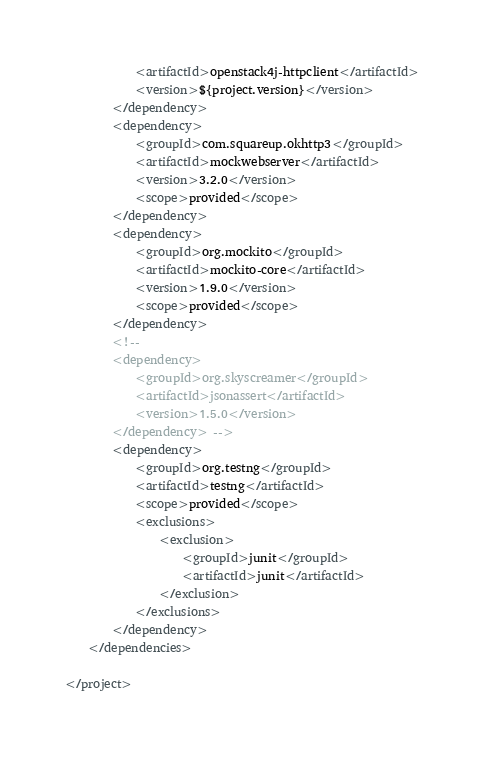Convert code to text. <code><loc_0><loc_0><loc_500><loc_500><_XML_>			<artifactId>openstack4j-httpclient</artifactId>
			<version>${project.version}</version>
		</dependency>
		<dependency>
			<groupId>com.squareup.okhttp3</groupId>
			<artifactId>mockwebserver</artifactId>
			<version>3.2.0</version>
			<scope>provided</scope>
		</dependency>
		<dependency>
			<groupId>org.mockito</groupId>
			<artifactId>mockito-core</artifactId>
			<version>1.9.0</version>
			<scope>provided</scope>
		</dependency>
		<!--
		<dependency>
		    <groupId>org.skyscreamer</groupId>
		    <artifactId>jsonassert</artifactId>
		    <version>1.5.0</version>
		</dependency> -->
		<dependency>
			<groupId>org.testng</groupId>
			<artifactId>testng</artifactId>
			<scope>provided</scope>
			<exclusions>
				<exclusion>
					<groupId>junit</groupId>
					<artifactId>junit</artifactId>
				</exclusion>
			</exclusions>
		</dependency>
	</dependencies>

</project>
</code> 